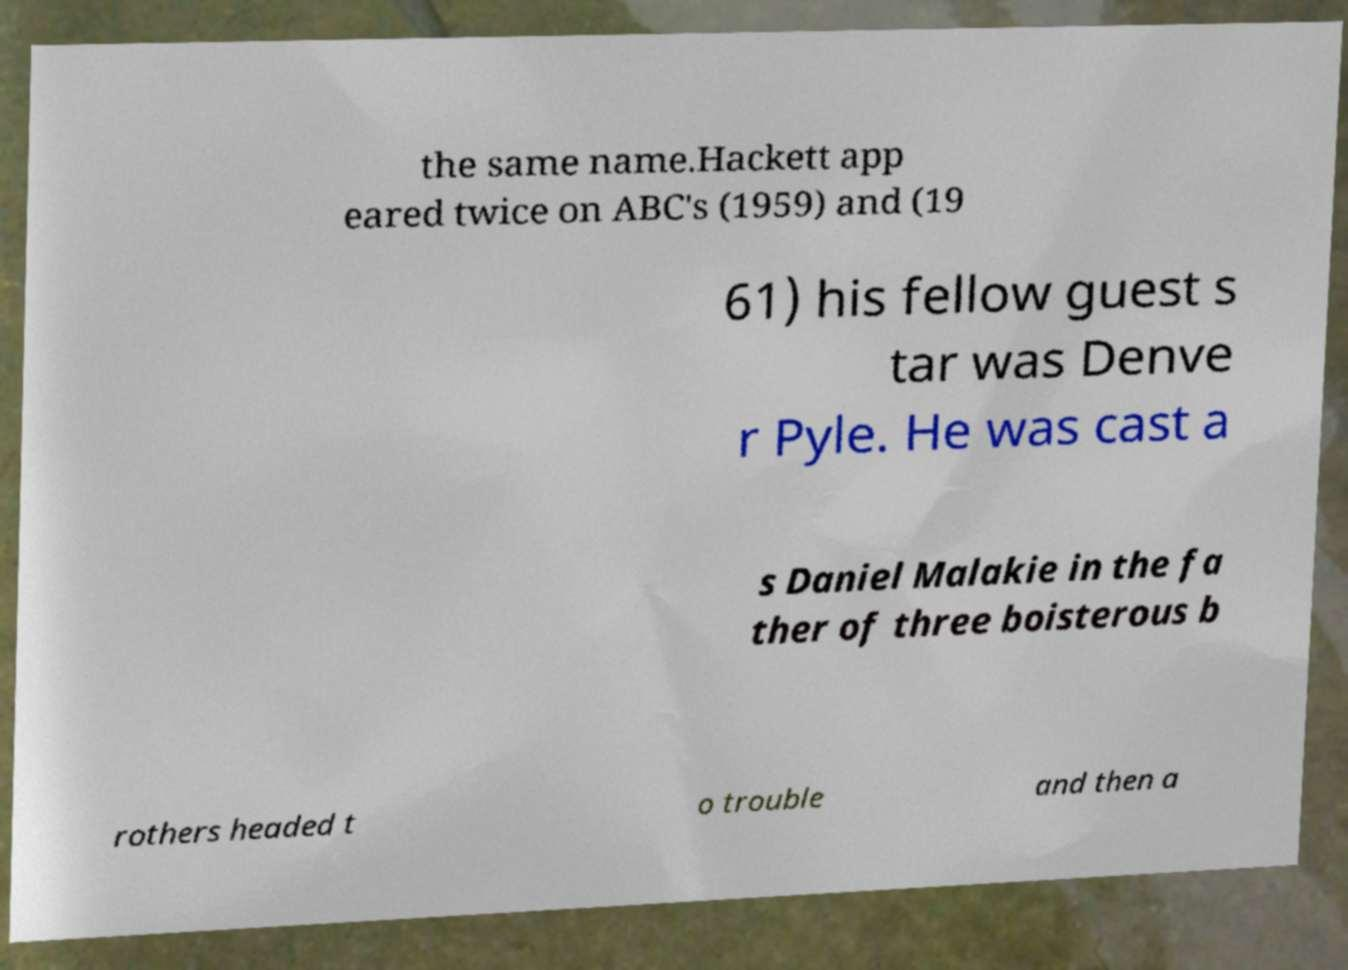For documentation purposes, I need the text within this image transcribed. Could you provide that? the same name.Hackett app eared twice on ABC's (1959) and (19 61) his fellow guest s tar was Denve r Pyle. He was cast a s Daniel Malakie in the fa ther of three boisterous b rothers headed t o trouble and then a 